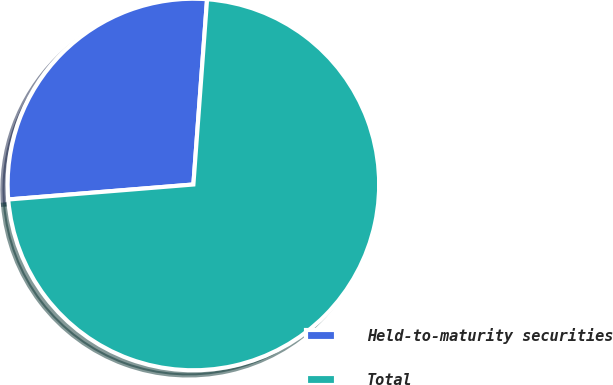<chart> <loc_0><loc_0><loc_500><loc_500><pie_chart><fcel>Held-to-maturity securities<fcel>Total<nl><fcel>27.46%<fcel>72.54%<nl></chart> 